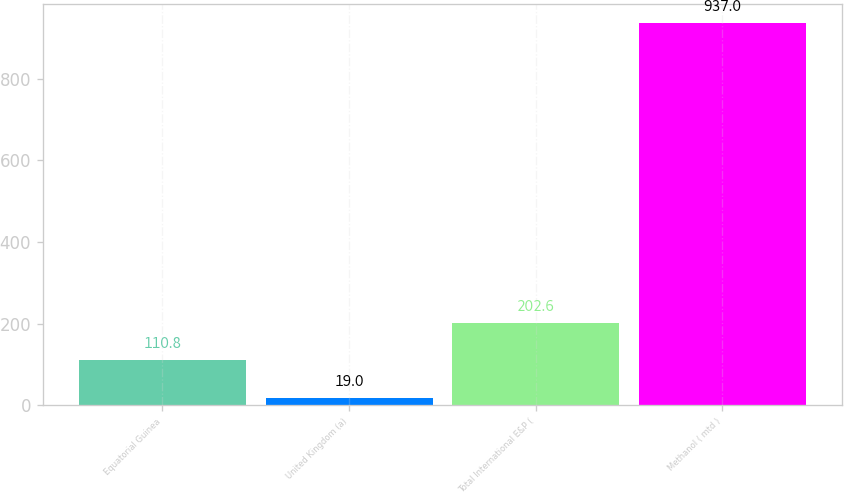Convert chart to OTSL. <chart><loc_0><loc_0><loc_500><loc_500><bar_chart><fcel>Equatorial Guinea<fcel>United Kingdom (a)<fcel>Total International E&P (<fcel>Methanol ( mtd )<nl><fcel>110.8<fcel>19<fcel>202.6<fcel>937<nl></chart> 